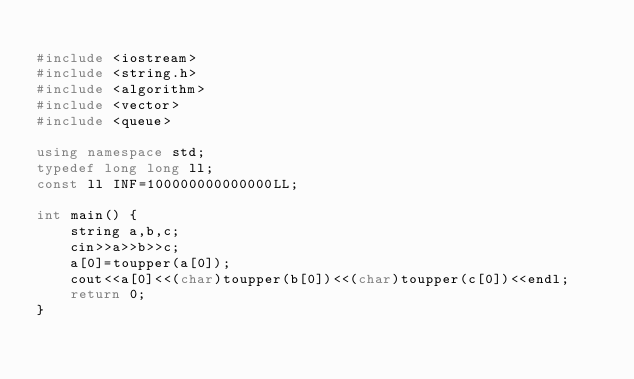Convert code to text. <code><loc_0><loc_0><loc_500><loc_500><_C++_>
#include <iostream>
#include <string.h>
#include <algorithm>
#include <vector>
#include <queue>

using namespace std;
typedef long long ll;
const ll INF=100000000000000LL;

int main() {
	string a,b,c;
	cin>>a>>b>>c;
	a[0]=toupper(a[0]);
	cout<<a[0]<<(char)toupper(b[0])<<(char)toupper(c[0])<<endl;
	return 0;
}
</code> 